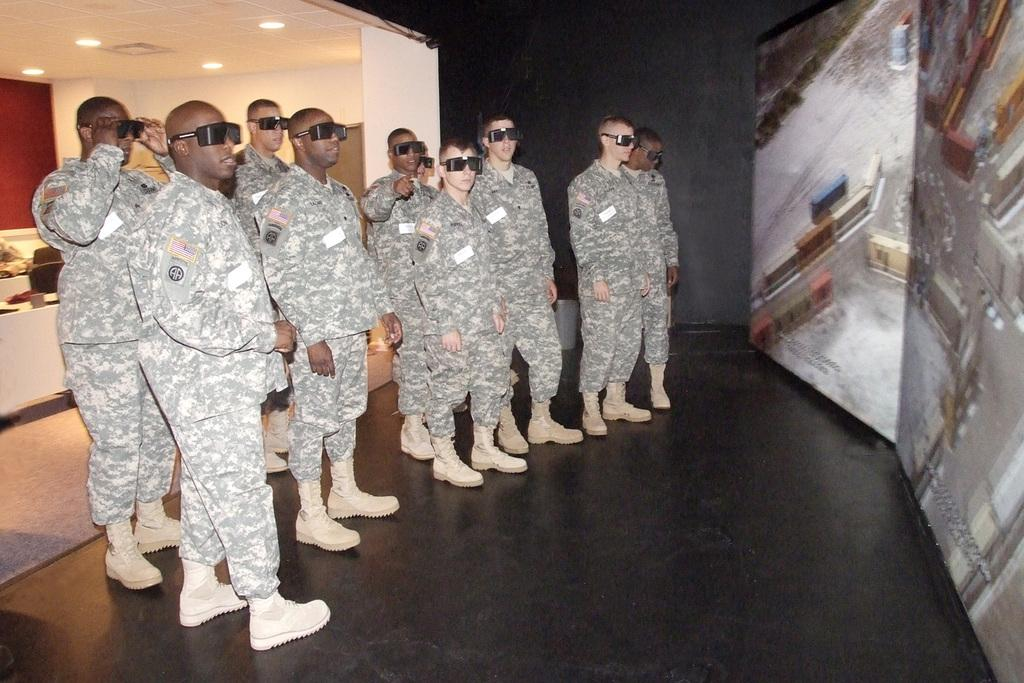What is located on the left side of the image? There is a group of Army men on the left side of the image. What are the Army men wearing? The Army men are wearing dresses, shoes, and goggles. What direction are the Army men looking in? The Army men are looking at the right side of the image. What can be seen on the ceiling in the image? There are ceiling lights on the left side of the image. How many toes are visible on the Army men in the image? The image does not show the Army men's toes, so it is not possible to determine how many toes are visible. 